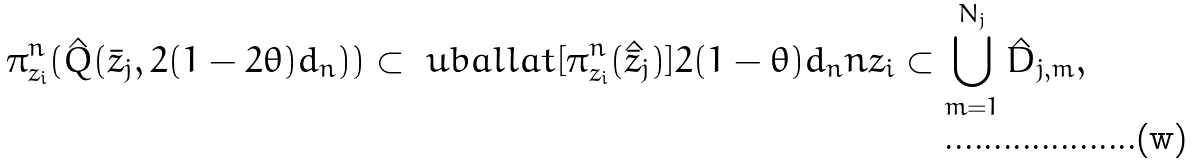<formula> <loc_0><loc_0><loc_500><loc_500>\pi ^ { n } _ { z _ { i } } ( \hat { Q } ( \bar { z } _ { j } , 2 ( 1 - 2 \theta ) d _ { n } ) ) \subset \ u b a l l a t [ \pi ^ { n } _ { z _ { i } } ( \hat { \bar { z } } _ { j } ) ] { 2 ( 1 - \theta ) d _ { n } } { n } { z _ { i } } \subset \bigcup _ { m = 1 } ^ { N _ { j } } \hat { D } _ { j , m } ,</formula> 